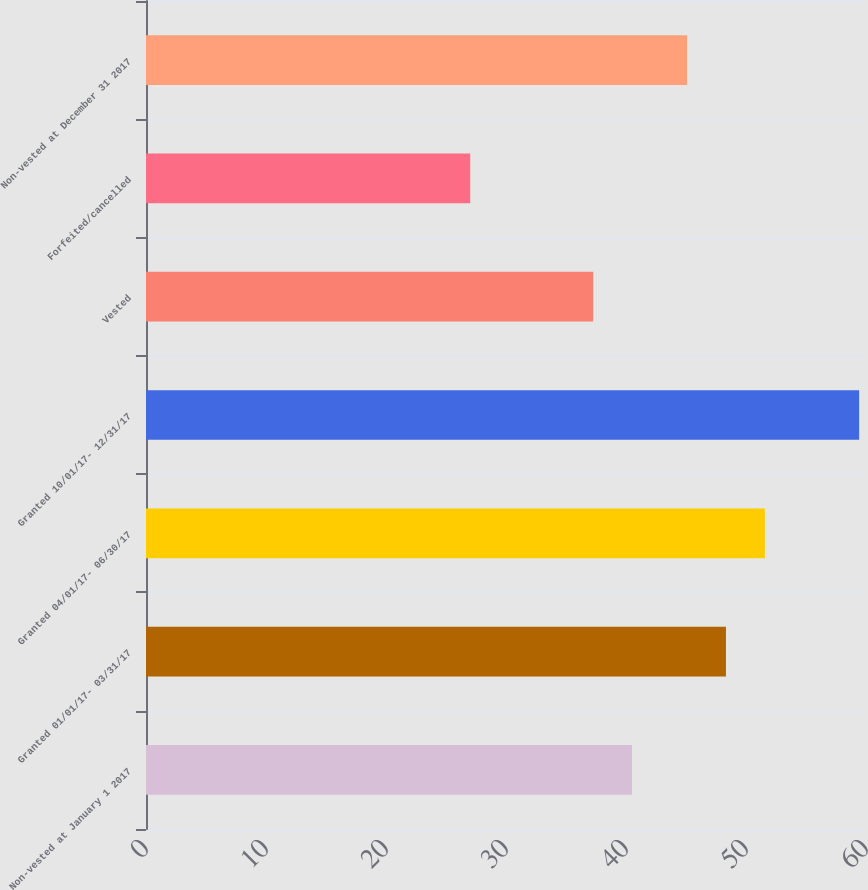Convert chart to OTSL. <chart><loc_0><loc_0><loc_500><loc_500><bar_chart><fcel>Non-vested at January 1 2017<fcel>Granted 01/01/17- 03/31/17<fcel>Granted 04/01/17- 06/30/17<fcel>Granted 10/01/17- 12/31/17<fcel>Vested<fcel>Forfeited/cancelled<fcel>Non-vested at December 31 2017<nl><fcel>40.5<fcel>48.33<fcel>51.57<fcel>59.43<fcel>37.26<fcel>27.02<fcel>45.09<nl></chart> 